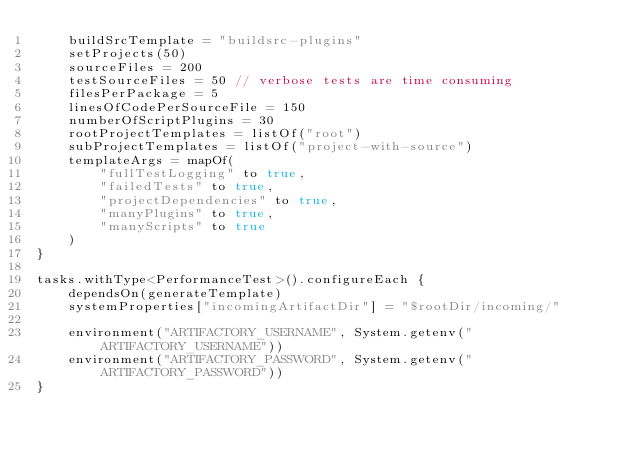<code> <loc_0><loc_0><loc_500><loc_500><_Kotlin_>    buildSrcTemplate = "buildsrc-plugins"
    setProjects(50)
    sourceFiles = 200
    testSourceFiles = 50 // verbose tests are time consuming
    filesPerPackage = 5
    linesOfCodePerSourceFile = 150
    numberOfScriptPlugins = 30
    rootProjectTemplates = listOf("root")
    subProjectTemplates = listOf("project-with-source")
    templateArgs = mapOf(
        "fullTestLogging" to true,
        "failedTests" to true,
        "projectDependencies" to true,
        "manyPlugins" to true,
        "manyScripts" to true
    )
}

tasks.withType<PerformanceTest>().configureEach {
    dependsOn(generateTemplate)
    systemProperties["incomingArtifactDir"] = "$rootDir/incoming/"

    environment("ARTIFACTORY_USERNAME", System.getenv("ARTIFACTORY_USERNAME"))
    environment("ARTIFACTORY_PASSWORD", System.getenv("ARTIFACTORY_PASSWORD"))
}
</code> 